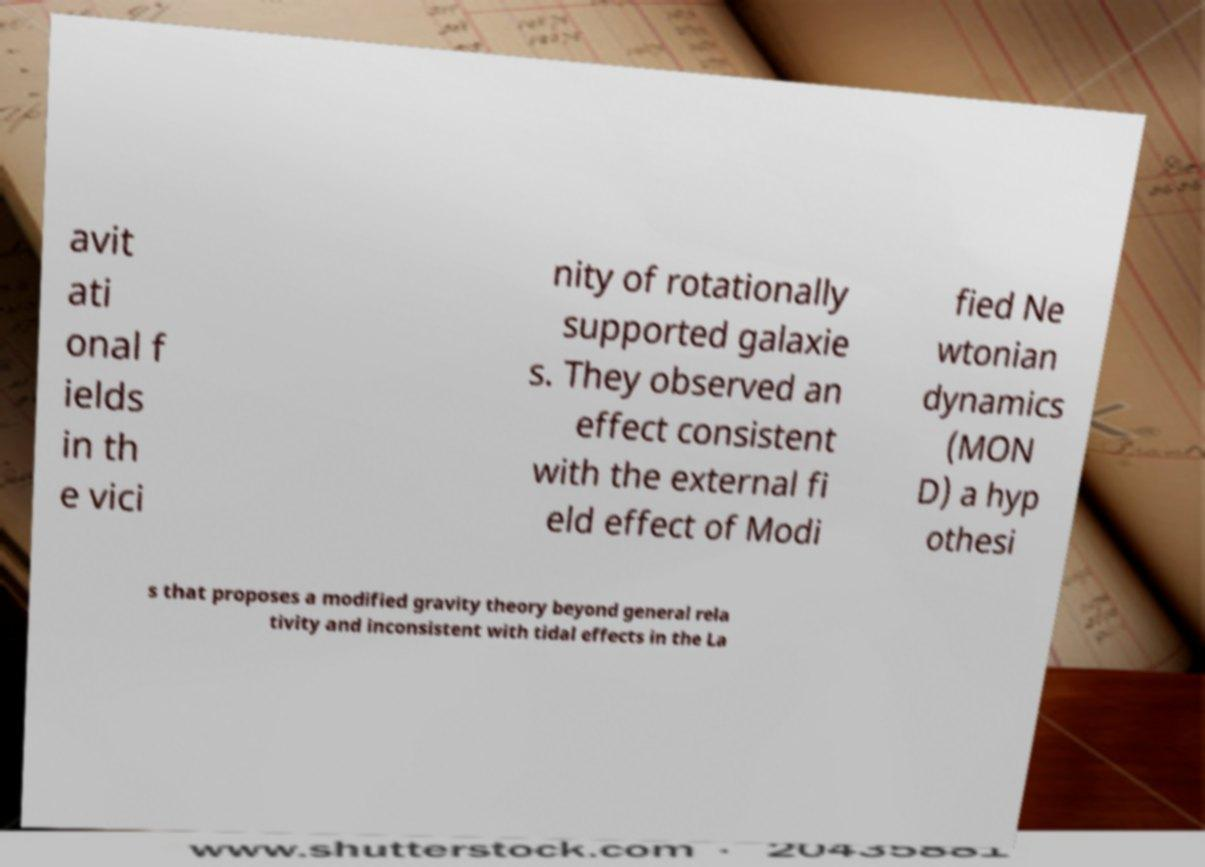Could you assist in decoding the text presented in this image and type it out clearly? avit ati onal f ields in th e vici nity of rotationally supported galaxie s. They observed an effect consistent with the external fi eld effect of Modi fied Ne wtonian dynamics (MON D) a hyp othesi s that proposes a modified gravity theory beyond general rela tivity and inconsistent with tidal effects in the La 